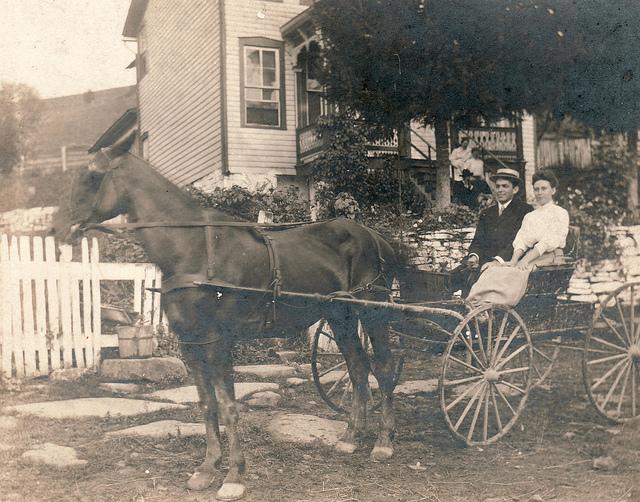How many women are wearing a hat?
Give a very brief answer. 0. Are there wheels on the wagon?
Be succinct. Yes. Are they going for a ride?
Answer briefly. Yes. What are these people sitting on?
Keep it brief. Carriage. 